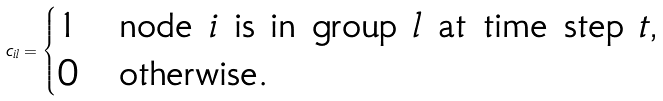Convert formula to latex. <formula><loc_0><loc_0><loc_500><loc_500>c _ { i l } = \begin{cases} 1 & \text {node $i$ is in group $l$ at time step $t$,} \\ 0 & \text {otherwise.} \end{cases}</formula> 